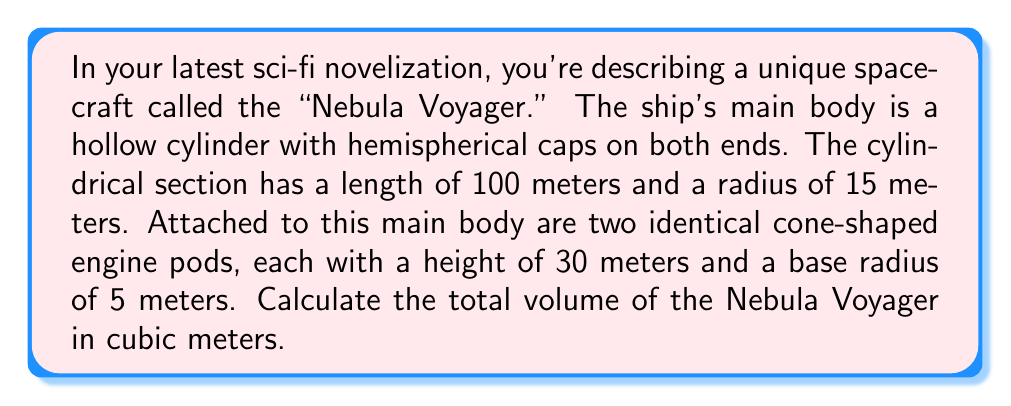What is the answer to this math problem? Let's break this down step-by-step:

1. Calculate the volume of the main body:
   a. Volume of cylinder: $V_c = \pi r^2 h$
      $$V_c = \pi \cdot 15^2 \cdot 100 = 70,685.83 \text{ m}^3$$
   b. Volume of two hemispheres: $V_h = \frac{4}{3}\pi r^3$
      $$V_h = 2 \cdot (\frac{2}{3}\pi \cdot 15^3) = 14,137.17 \text{ m}^3$$
   c. Total volume of main body: $V_{mb} = V_c + V_h = 84,823 \text{ m}^3$

2. Calculate the volume of one engine pod (cone):
   $V_{cone} = \frac{1}{3}\pi r^2 h$
   $$V_{cone} = \frac{1}{3}\pi \cdot 5^2 \cdot 30 = 785.40 \text{ m}^3$$

3. Total volume of both engine pods:
   $V_{pods} = 2 \cdot V_{cone} = 1,570.80 \text{ m}^3$

4. Calculate the total volume of the Nebula Voyager:
   $V_{total} = V_{mb} + V_{pods} = 84,823 + 1,570.80 = 86,393.80 \text{ m}^3$

[asy]
import three;

size(200);
currentprojection=perspective(6,3,2);

// Main body
draw(cylinder((0,0,0),15,100));
draw(shift(0,0,100)*scale3(15)*unitsphere);
draw(scale3(15)*unitsphere);

// Engine pods
draw(shift(20,0,50)*rotate(90,Y)*cone(5,30));
draw(shift(-20,0,50)*rotate(90,Y)*cone(5,30));

[/asy]
Answer: $86,393.80 \text{ m}^3$ 